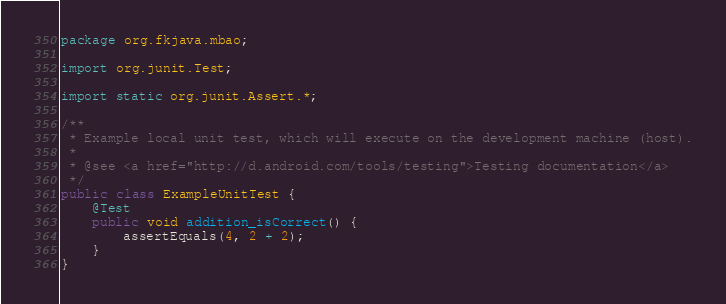Convert code to text. <code><loc_0><loc_0><loc_500><loc_500><_Java_>package org.fkjava.mbao;

import org.junit.Test;

import static org.junit.Assert.*;

/**
 * Example local unit test, which will execute on the development machine (host).
 *
 * @see <a href="http://d.android.com/tools/testing">Testing documentation</a>
 */
public class ExampleUnitTest {
    @Test
    public void addition_isCorrect() {
        assertEquals(4, 2 + 2);
    }
}</code> 